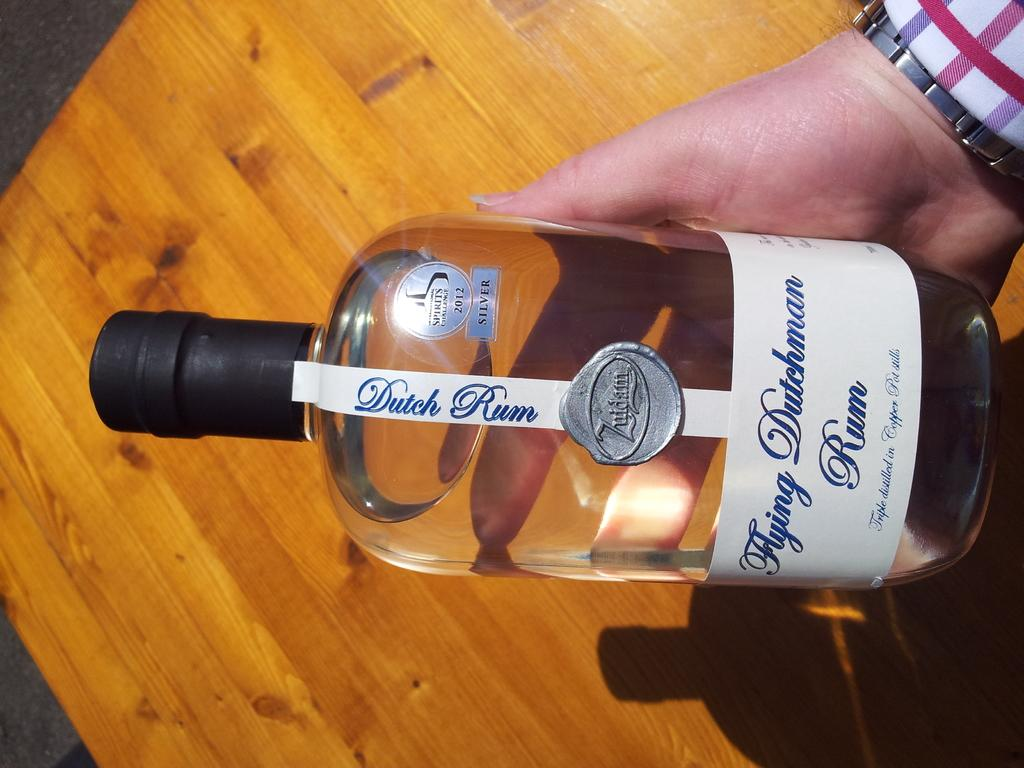<image>
Relay a brief, clear account of the picture shown. A man wearing a plaid shirt holds a closed bottle of Dutch Rum sideways over a wooden floor. 